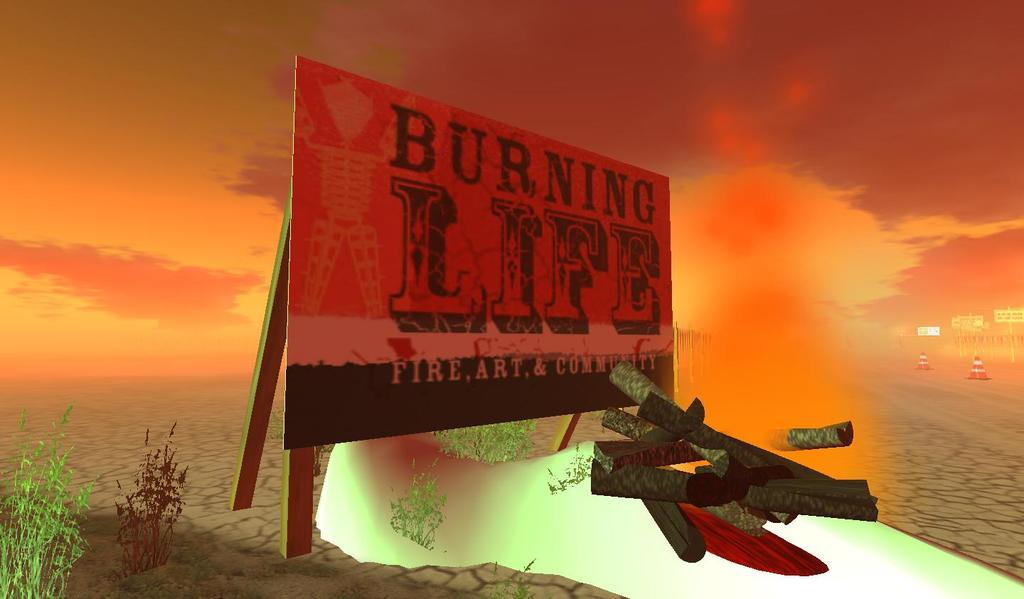<image>
Render a clear and concise summary of the photo. The sign in the desert says Burning Life 